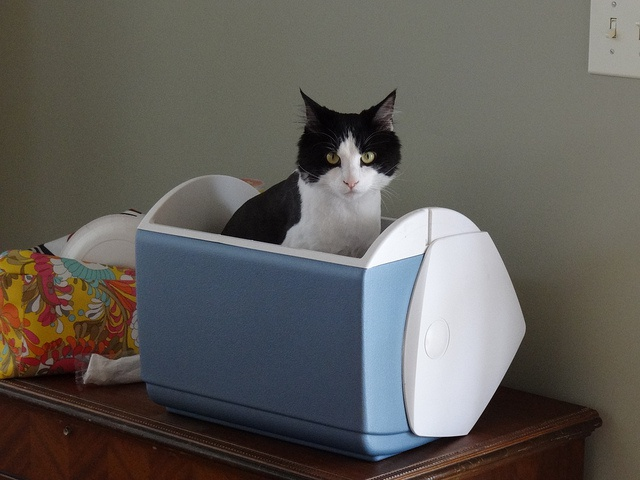Describe the objects in this image and their specific colors. I can see a cat in black, darkgray, gray, and lightgray tones in this image. 